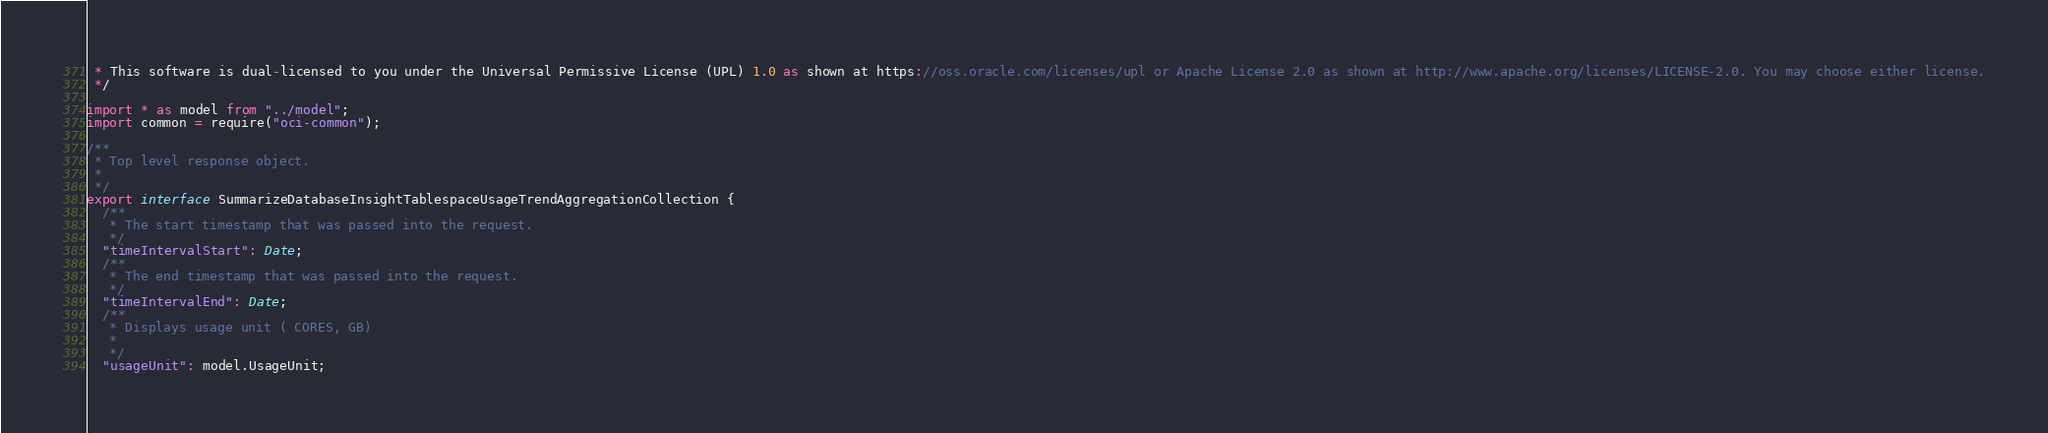<code> <loc_0><loc_0><loc_500><loc_500><_TypeScript_> * This software is dual-licensed to you under the Universal Permissive License (UPL) 1.0 as shown at https://oss.oracle.com/licenses/upl or Apache License 2.0 as shown at http://www.apache.org/licenses/LICENSE-2.0. You may choose either license.
 */

import * as model from "../model";
import common = require("oci-common");

/**
 * Top level response object.
 *
 */
export interface SummarizeDatabaseInsightTablespaceUsageTrendAggregationCollection {
  /**
   * The start timestamp that was passed into the request.
   */
  "timeIntervalStart": Date;
  /**
   * The end timestamp that was passed into the request.
   */
  "timeIntervalEnd": Date;
  /**
   * Displays usage unit ( CORES, GB)
   *
   */
  "usageUnit": model.UsageUnit;</code> 